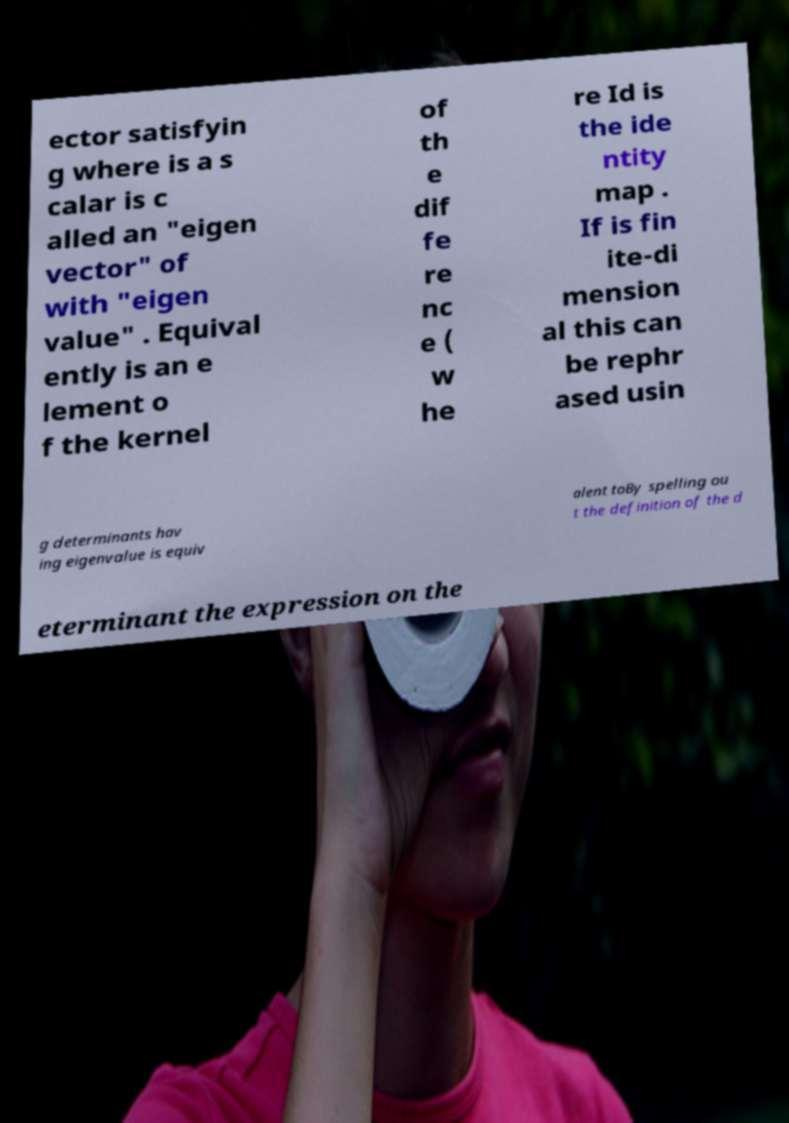Please read and relay the text visible in this image. What does it say? ector satisfyin g where is a s calar is c alled an "eigen vector" of with "eigen value" . Equival ently is an e lement o f the kernel of th e dif fe re nc e ( w he re Id is the ide ntity map . If is fin ite-di mension al this can be rephr ased usin g determinants hav ing eigenvalue is equiv alent toBy spelling ou t the definition of the d eterminant the expression on the 